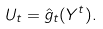Convert formula to latex. <formula><loc_0><loc_0><loc_500><loc_500>U _ { t } = \hat { g } _ { t } ( Y ^ { t } ) .</formula> 